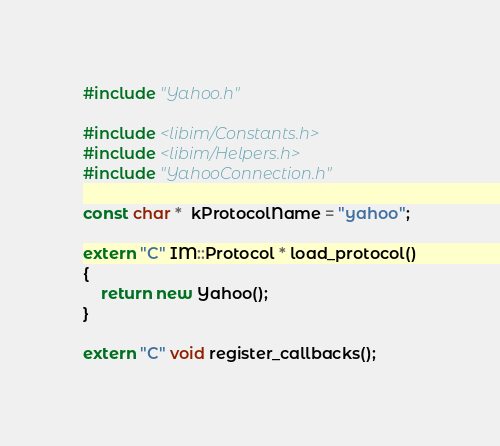Convert code to text. <code><loc_0><loc_0><loc_500><loc_500><_C++_>#include "Yahoo.h"

#include <libim/Constants.h>
#include <libim/Helpers.h>
#include "YahooConnection.h"

const char *  kProtocolName = "yahoo";

extern "C" IM::Protocol * load_protocol()
{
	return new Yahoo();
}

extern "C" void register_callbacks();
</code> 